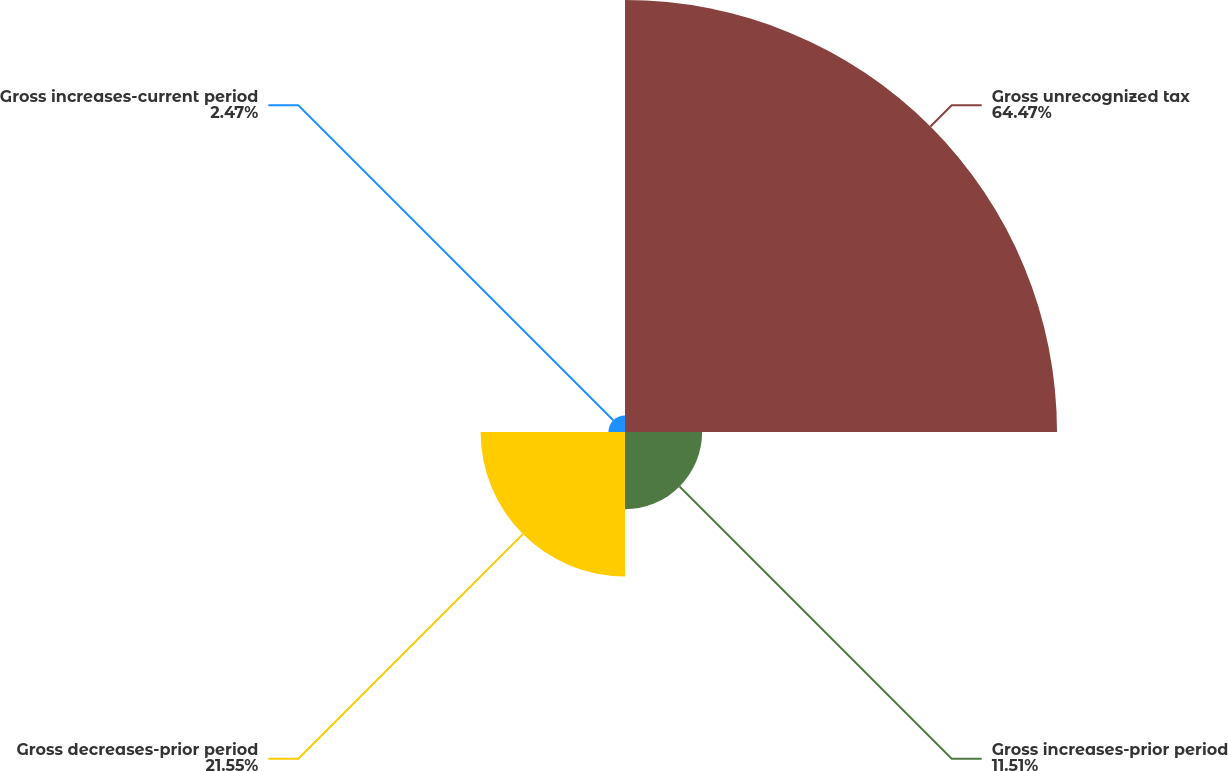Convert chart to OTSL. <chart><loc_0><loc_0><loc_500><loc_500><pie_chart><fcel>Gross unrecognized tax<fcel>Gross increases-prior period<fcel>Gross decreases-prior period<fcel>Gross increases-current period<nl><fcel>64.47%<fcel>11.51%<fcel>21.55%<fcel>2.47%<nl></chart> 